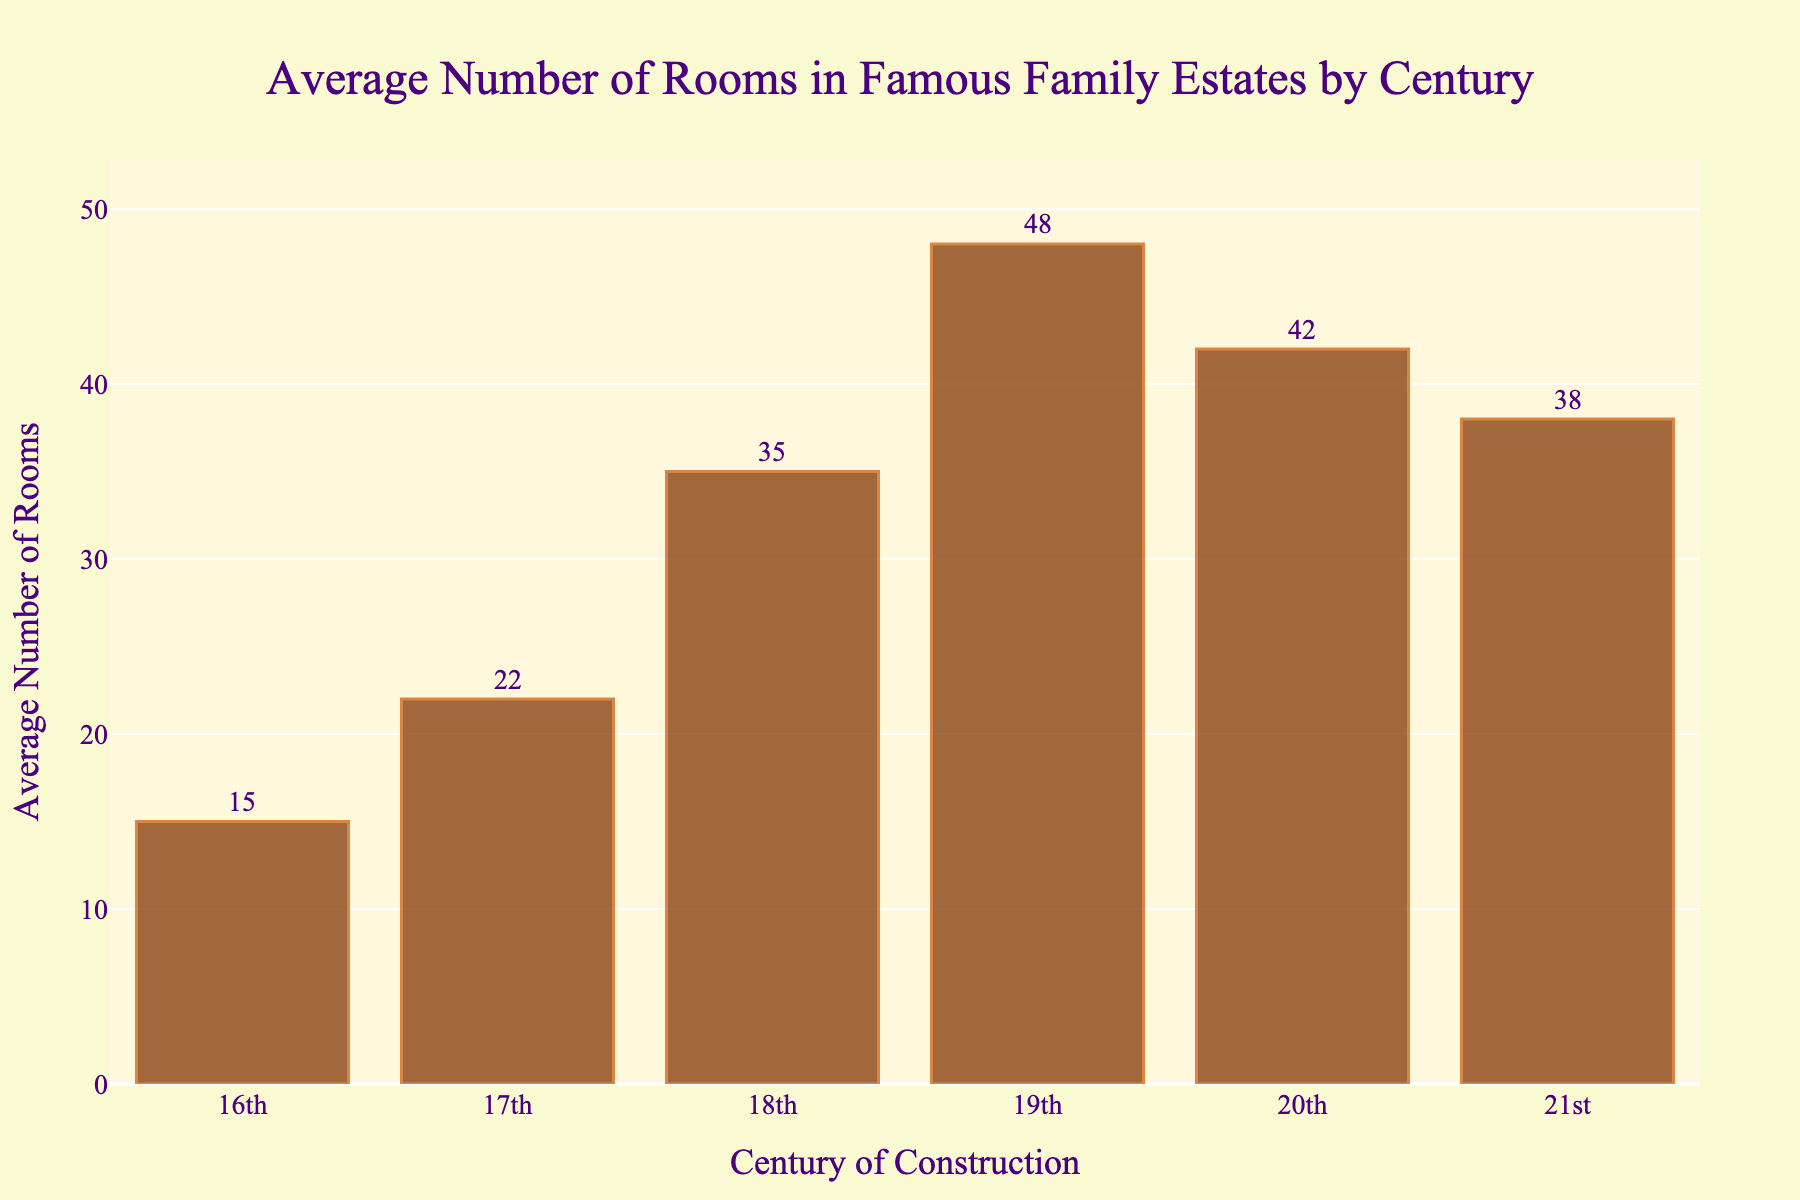how many more rooms on average were in estates built in the 19th century compared to the 16th century? The average number of rooms in estates from the 19th century is 48, and for the 16th century, it is 15. Subtracting the number from the 16th century from the 19th century gives 48 - 15 = 33.
Answer: 33 Which century had the highest average number of rooms in family estates? By comparing the height of the bars, the 19th century has the highest bar with an average number of rooms of 48.
Answer: 19th century Were the average number of rooms in the 20th century greater than or equal to the average number of rooms in the 21st century? The bar for the 20th century is at 42, and the bar for the 21st century is at 38. Since 42 is greater than 38, the average number of rooms in the 20th century is greater than in the 21st century.
Answer: Greater What is the average number of rooms in estates for the 16th, 17th, and 18th centuries combined? The average number of rooms for the 16th century is 15, for the 17th century is 22, and for the 18th century is 35. Adding these together, we get 15 + 22 + 35 = 72. Dividing by 3 for the average, we get 72 / 3 = 24.
Answer: 24 By how much did the average number of rooms in family estates increase from the 17th to the 18th century? The average number of rooms in the 17th century is 22, and in the 18th century, it is 35. Subtracting the 17th century from the 18th century gives 35 - 22 = 13.
Answer: 13 In which century did the average number of rooms increase the most compared to the previous century? Comparing successive centuries: 
- From 16th to 17th: 22 - 15 = 7
- From 17th to 18th: 35 - 22 = 13
- From 18th to 19th: 48 - 35 = 13
- From 19th to 20th: 42 - 48 = -6
- From 20th to 21st: 38 - 42 = -4
The largest increase is from 17th to 18th and 18th to 19th, both with an increase of 13.
Answer: 18th century or 19th century On average, how many more rooms were there in estates built in the 21st century compared to the 16th century? The average number of rooms in the 21st century is 38, and in the 16th century, it is 15. Subtracting the number from the 16th century from the 21st century gives 38 - 15 = 23.
Answer: 23 